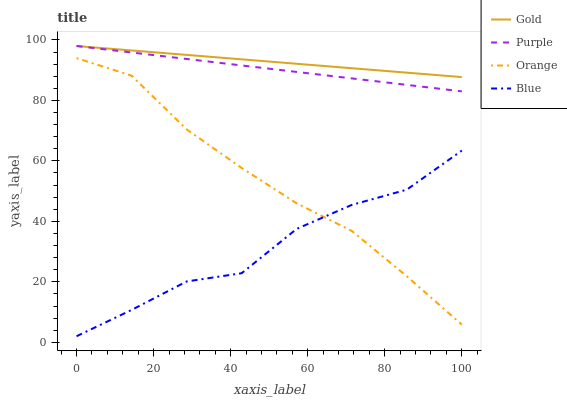Does Blue have the minimum area under the curve?
Answer yes or no. Yes. Does Gold have the maximum area under the curve?
Answer yes or no. Yes. Does Orange have the minimum area under the curve?
Answer yes or no. No. Does Orange have the maximum area under the curve?
Answer yes or no. No. Is Gold the smoothest?
Answer yes or no. Yes. Is Blue the roughest?
Answer yes or no. Yes. Is Orange the smoothest?
Answer yes or no. No. Is Orange the roughest?
Answer yes or no. No. Does Blue have the lowest value?
Answer yes or no. Yes. Does Orange have the lowest value?
Answer yes or no. No. Does Gold have the highest value?
Answer yes or no. Yes. Does Orange have the highest value?
Answer yes or no. No. Is Orange less than Gold?
Answer yes or no. Yes. Is Gold greater than Blue?
Answer yes or no. Yes. Does Gold intersect Purple?
Answer yes or no. Yes. Is Gold less than Purple?
Answer yes or no. No. Is Gold greater than Purple?
Answer yes or no. No. Does Orange intersect Gold?
Answer yes or no. No. 